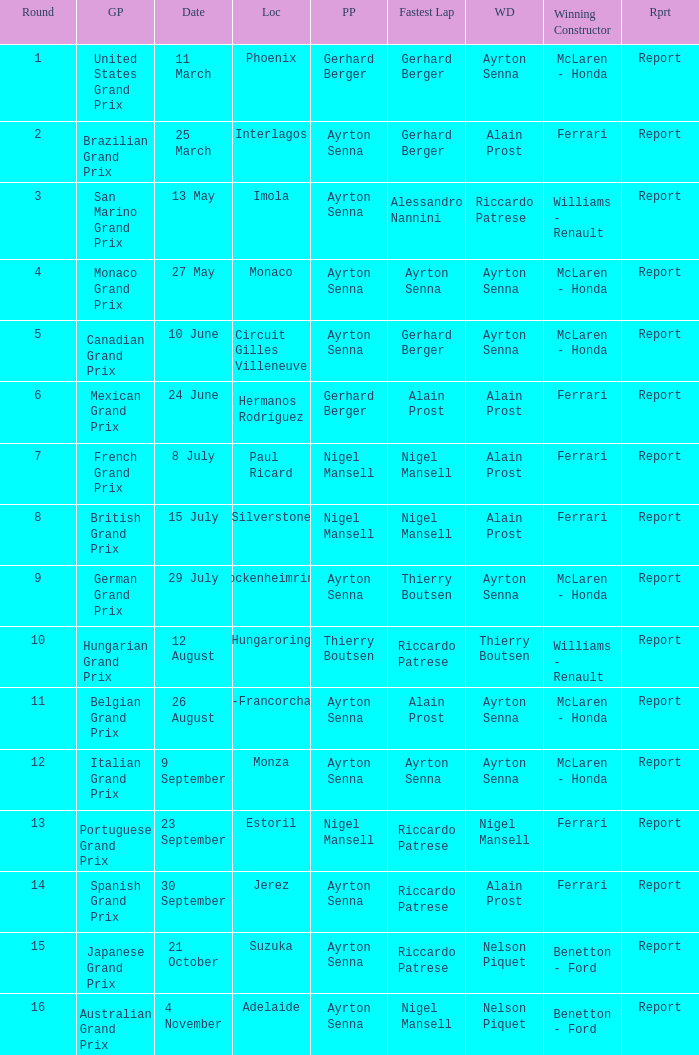What is the date that Ayrton Senna was the drive in Monza? 9 September. 